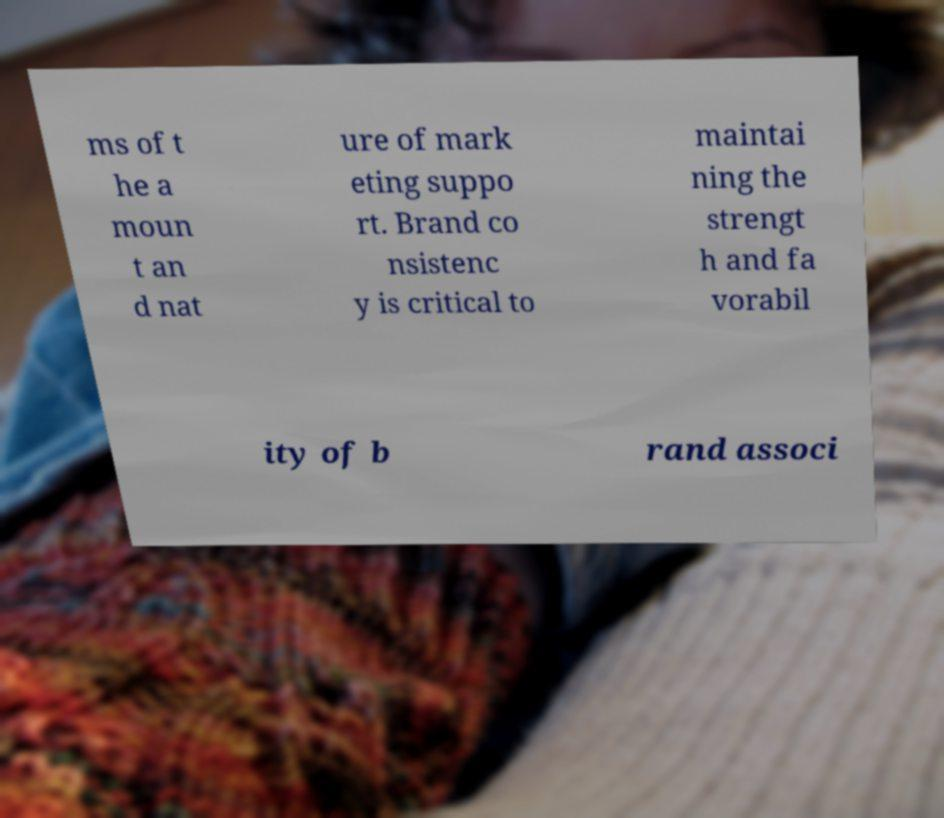Could you assist in decoding the text presented in this image and type it out clearly? ms of t he a moun t an d nat ure of mark eting suppo rt. Brand co nsistenc y is critical to maintai ning the strengt h and fa vorabil ity of b rand associ 